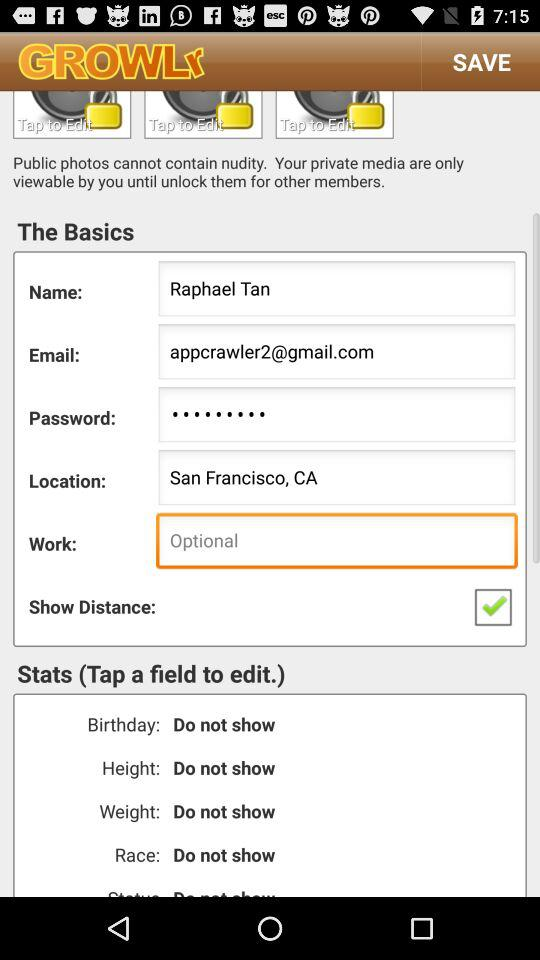What is the date of birth? The date of birth is not shown. 